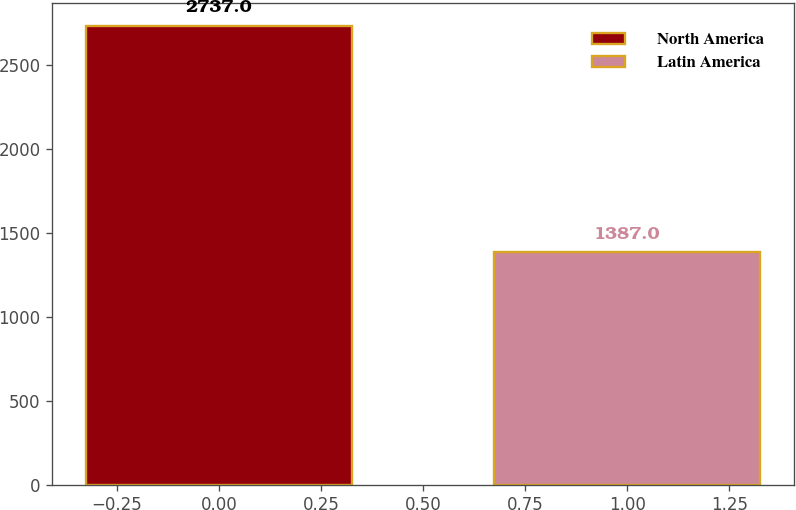Convert chart to OTSL. <chart><loc_0><loc_0><loc_500><loc_500><bar_chart><fcel>North America<fcel>Latin America<nl><fcel>2737<fcel>1387<nl></chart> 